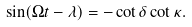<formula> <loc_0><loc_0><loc_500><loc_500>\sin ( \Omega t - \lambda ) = - \cot \delta \cot \kappa .</formula> 